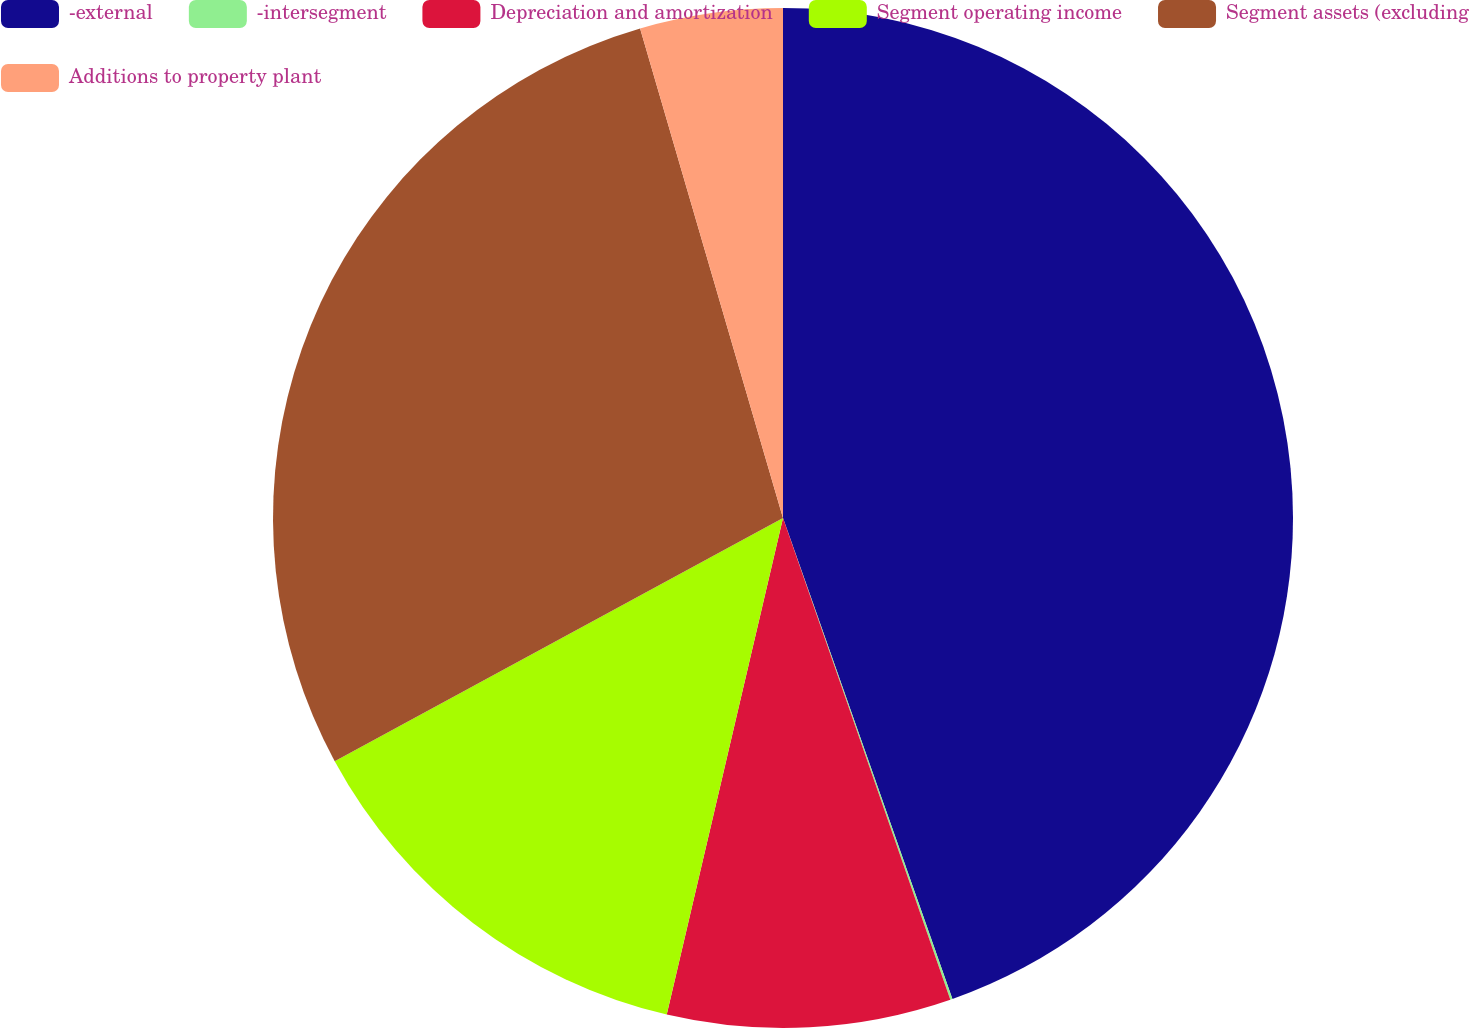Convert chart to OTSL. <chart><loc_0><loc_0><loc_500><loc_500><pie_chart><fcel>-external<fcel>-intersegment<fcel>Depreciation and amortization<fcel>Segment operating income<fcel>Segment assets (excluding<fcel>Additions to property plant<nl><fcel>44.61%<fcel>0.07%<fcel>8.98%<fcel>13.43%<fcel>28.39%<fcel>4.52%<nl></chart> 